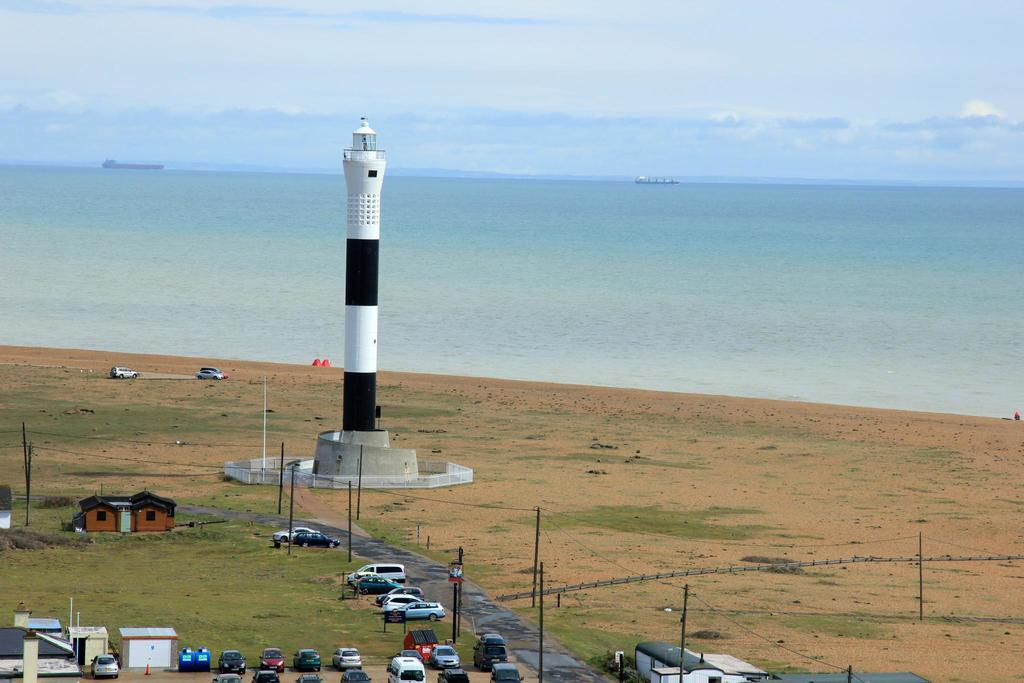What is the main structure in the image? There is a lighthouse in the image. What feature surrounds the lighthouse? There is a railing around the lighthouse. What can be seen near the lighthouse? There is a road near the lighthouse. What other objects are present in the image? There are poles, buildings, and vehicles in the image. What can be seen in the background of the image? There is water and sky visible in the background of the image. How many lizards can be seen climbing the lighthouse in the image? There are no lizards present in the image. What type of watch is the lighthouse wearing in the image? The lighthouse is not a living being and therefore cannot wear a watch. 